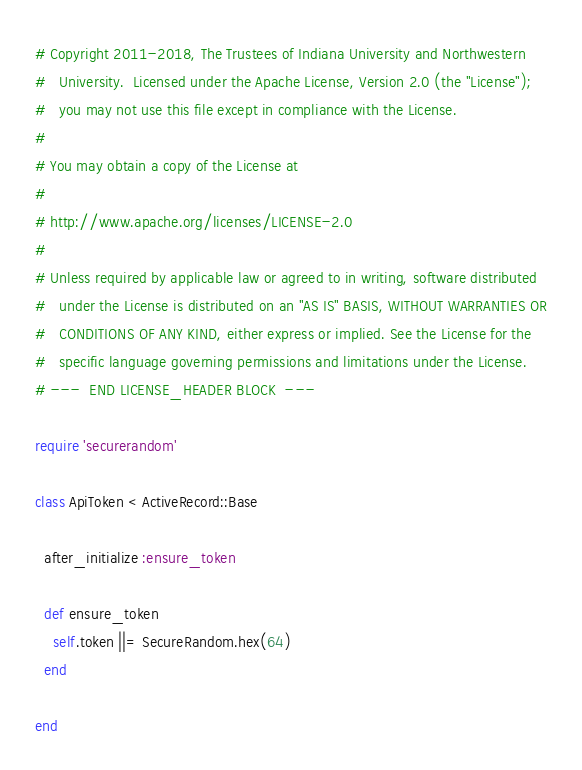Convert code to text. <code><loc_0><loc_0><loc_500><loc_500><_Ruby_># Copyright 2011-2018, The Trustees of Indiana University and Northwestern
#   University.  Licensed under the Apache License, Version 2.0 (the "License");
#   you may not use this file except in compliance with the License.
# 
# You may obtain a copy of the License at
# 
# http://www.apache.org/licenses/LICENSE-2.0
# 
# Unless required by applicable law or agreed to in writing, software distributed
#   under the License is distributed on an "AS IS" BASIS, WITHOUT WARRANTIES OR
#   CONDITIONS OF ANY KIND, either express or implied. See the License for the
#   specific language governing permissions and limitations under the License.
# ---  END LICENSE_HEADER BLOCK  ---

require 'securerandom'

class ApiToken < ActiveRecord::Base
  
  after_initialize :ensure_token
  
  def ensure_token
    self.token ||= SecureRandom.hex(64)
  end
  
end
</code> 